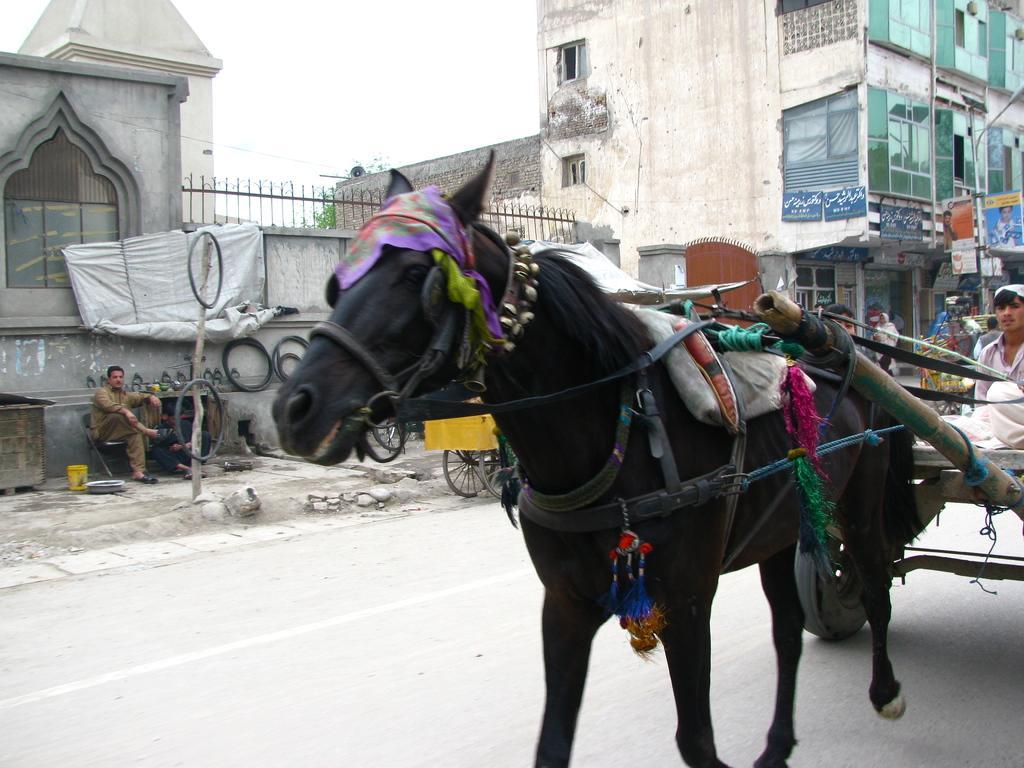How would you summarize this image in a sentence or two? This picture is clicked outside the city. The man in the white shirt is riding the horse cart. On the right side, we see people are standing. Beside them, we see a building and a street light. We see banners. On the right side, we see a man is sitting on the chair. Beside him,we see the tyres. Behind him, we see building and a railing. 